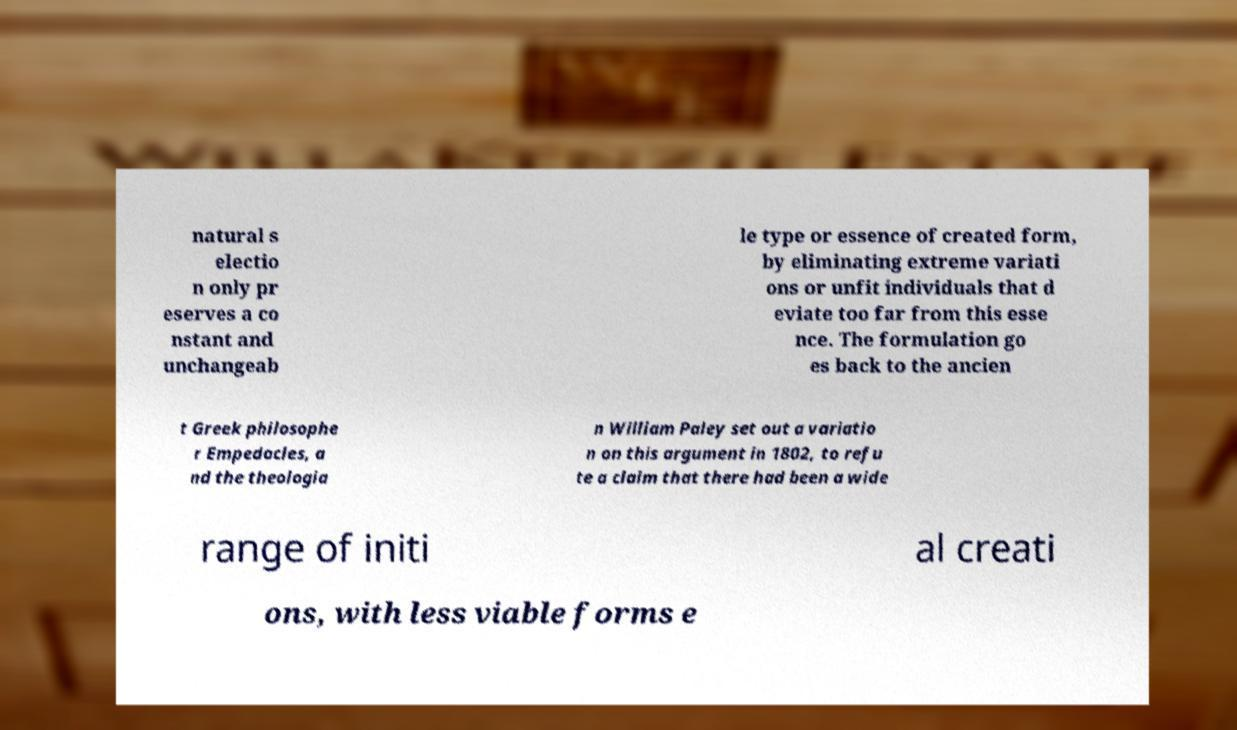There's text embedded in this image that I need extracted. Can you transcribe it verbatim? natural s electio n only pr eserves a co nstant and unchangeab le type or essence of created form, by eliminating extreme variati ons or unfit individuals that d eviate too far from this esse nce. The formulation go es back to the ancien t Greek philosophe r Empedocles, a nd the theologia n William Paley set out a variatio n on this argument in 1802, to refu te a claim that there had been a wide range of initi al creati ons, with less viable forms e 